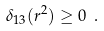<formula> <loc_0><loc_0><loc_500><loc_500>\delta _ { 1 3 } ( r ^ { 2 } ) \geq 0 \ .</formula> 